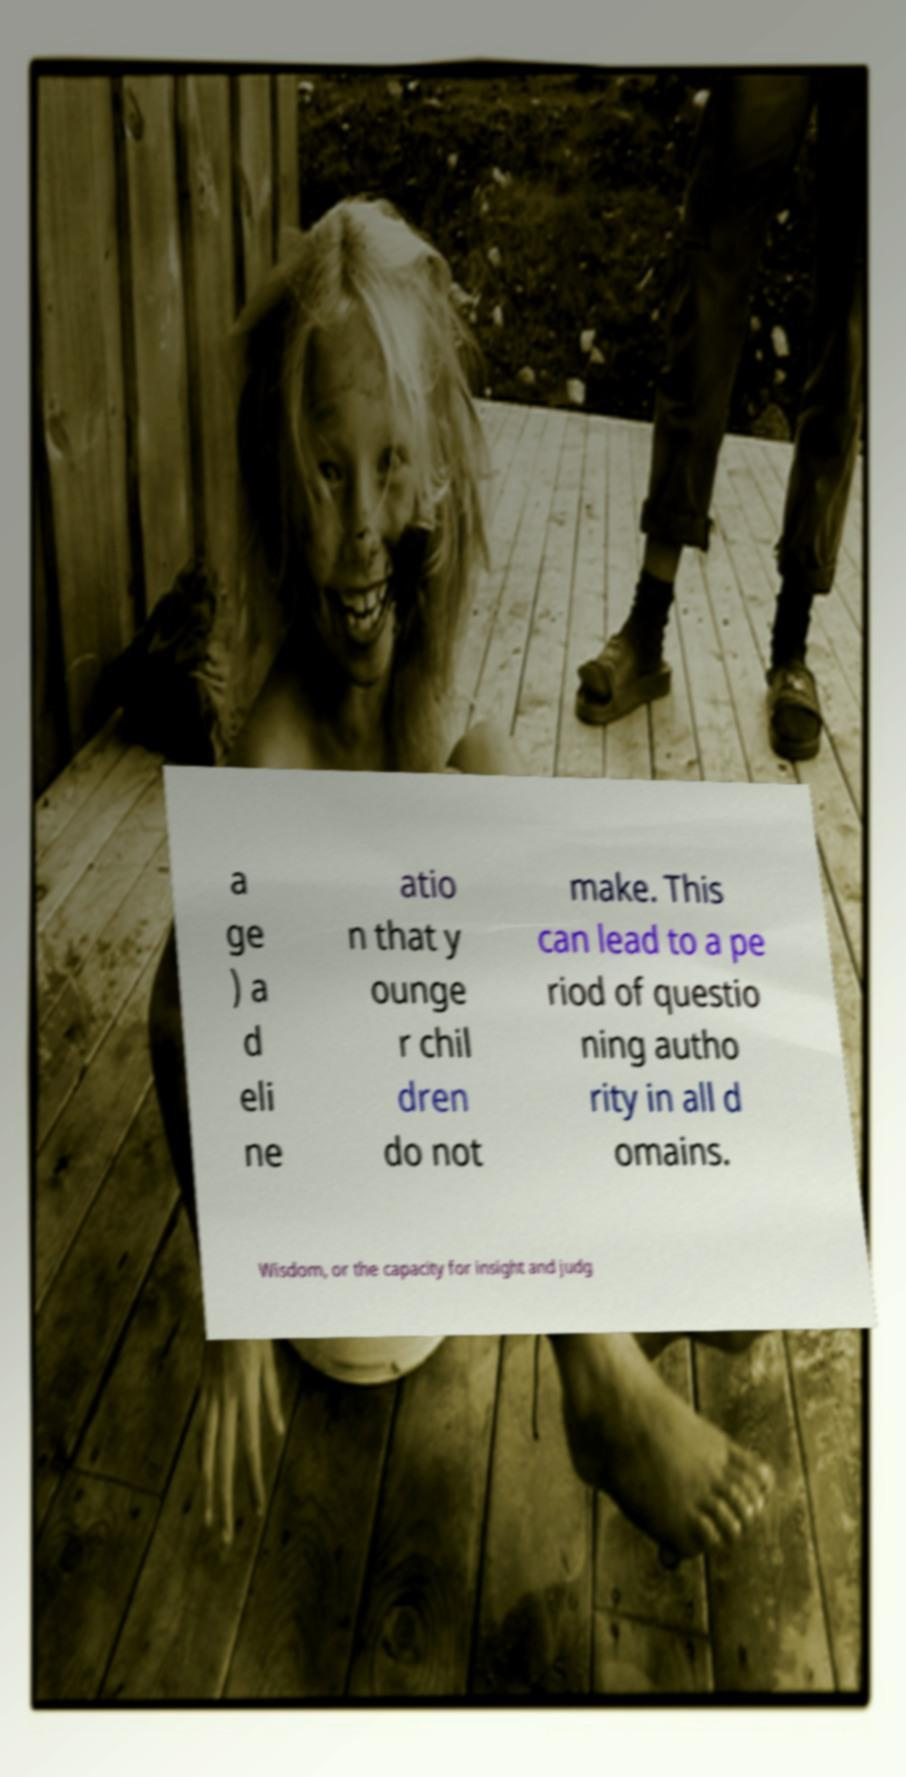Can you accurately transcribe the text from the provided image for me? a ge ) a d eli ne atio n that y ounge r chil dren do not make. This can lead to a pe riod of questio ning autho rity in all d omains. Wisdom, or the capacity for insight and judg 